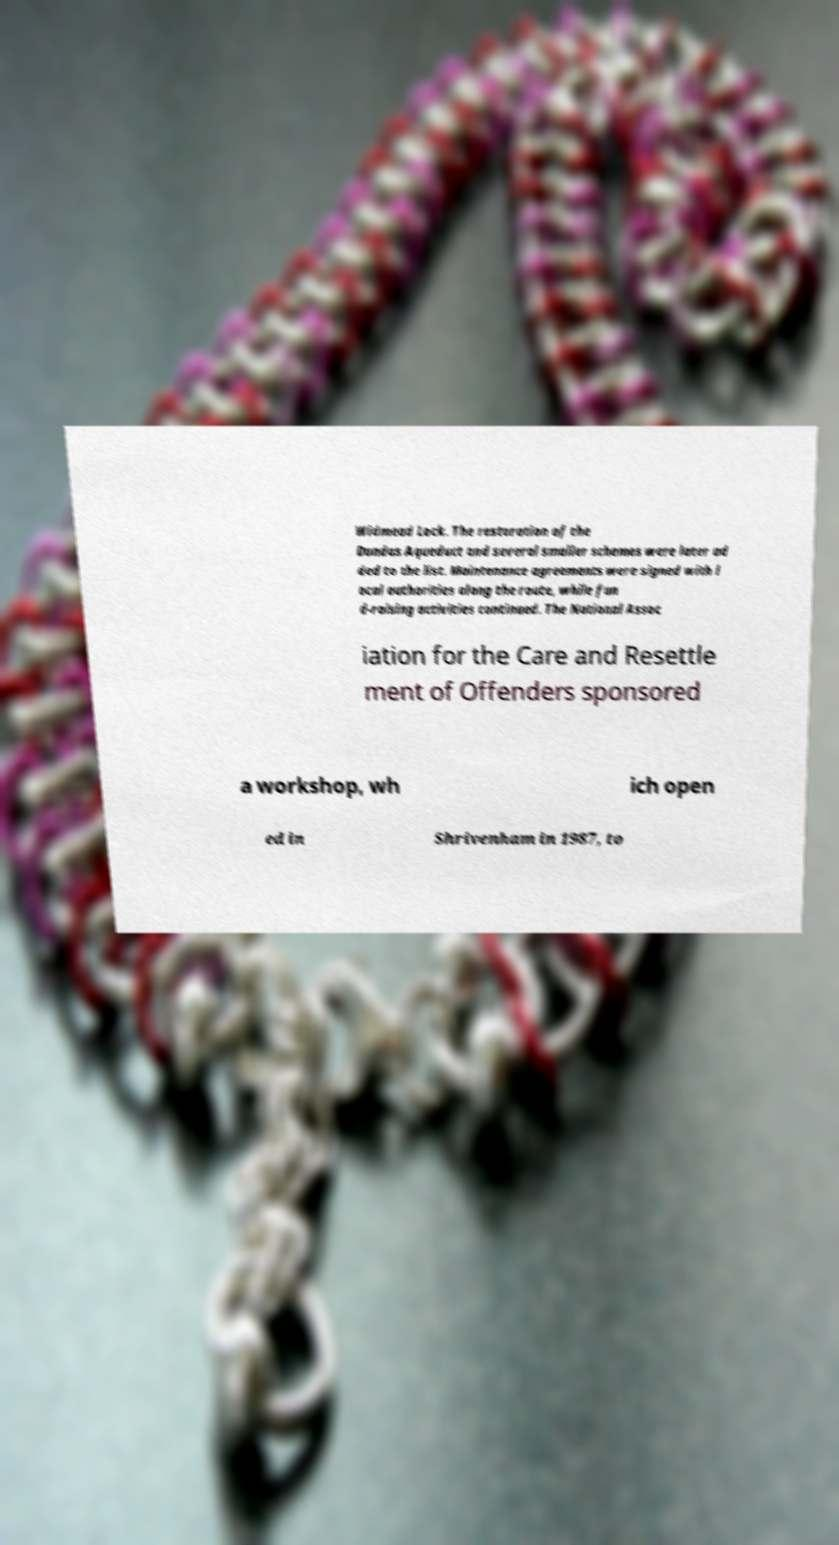Could you assist in decoding the text presented in this image and type it out clearly? Widmead Lock. The restoration of the Dundas Aqueduct and several smaller schemes were later ad ded to the list. Maintenance agreements were signed with l ocal authorities along the route, while fun d-raising activities continued. The National Assoc iation for the Care and Resettle ment of Offenders sponsored a workshop, wh ich open ed in Shrivenham in 1987, to 